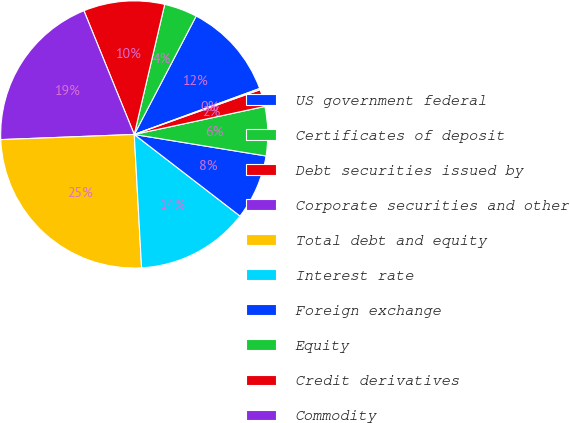Convert chart. <chart><loc_0><loc_0><loc_500><loc_500><pie_chart><fcel>US government federal<fcel>Certificates of deposit<fcel>Debt securities issued by<fcel>Corporate securities and other<fcel>Total debt and equity<fcel>Interest rate<fcel>Foreign exchange<fcel>Equity<fcel>Credit derivatives<fcel>Commodity<nl><fcel>11.74%<fcel>4.01%<fcel>9.81%<fcel>19.47%<fcel>25.26%<fcel>13.67%<fcel>7.88%<fcel>5.94%<fcel>2.08%<fcel>0.15%<nl></chart> 